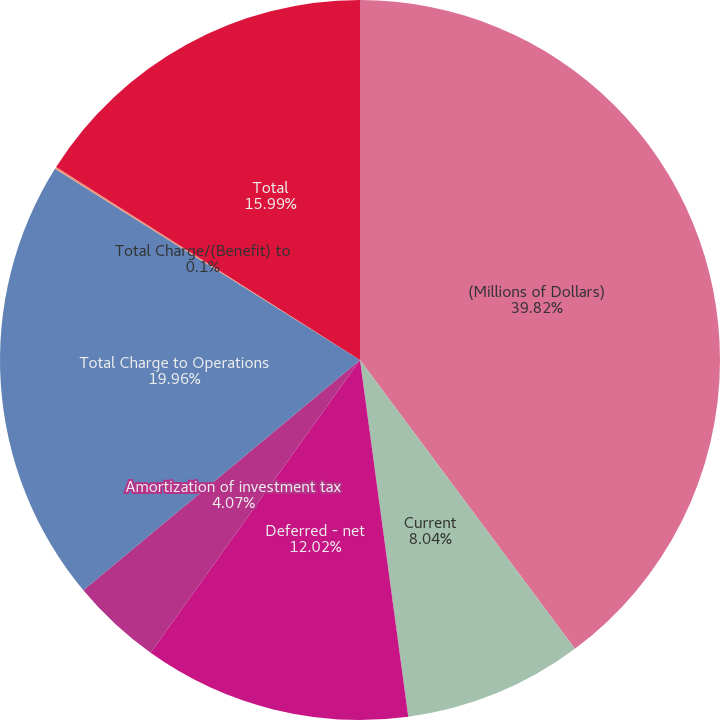Convert chart to OTSL. <chart><loc_0><loc_0><loc_500><loc_500><pie_chart><fcel>(Millions of Dollars)<fcel>Current<fcel>Deferred - net<fcel>Amortization of investment tax<fcel>Total Charge to Operations<fcel>Total Charge/(Benefit) to<fcel>Total<nl><fcel>39.82%<fcel>8.04%<fcel>12.02%<fcel>4.07%<fcel>19.96%<fcel>0.1%<fcel>15.99%<nl></chart> 